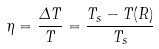Convert formula to latex. <formula><loc_0><loc_0><loc_500><loc_500>\eta = \frac { \Delta T } { T } = \frac { T _ { s } - T ( R ) } { T _ { s } }</formula> 